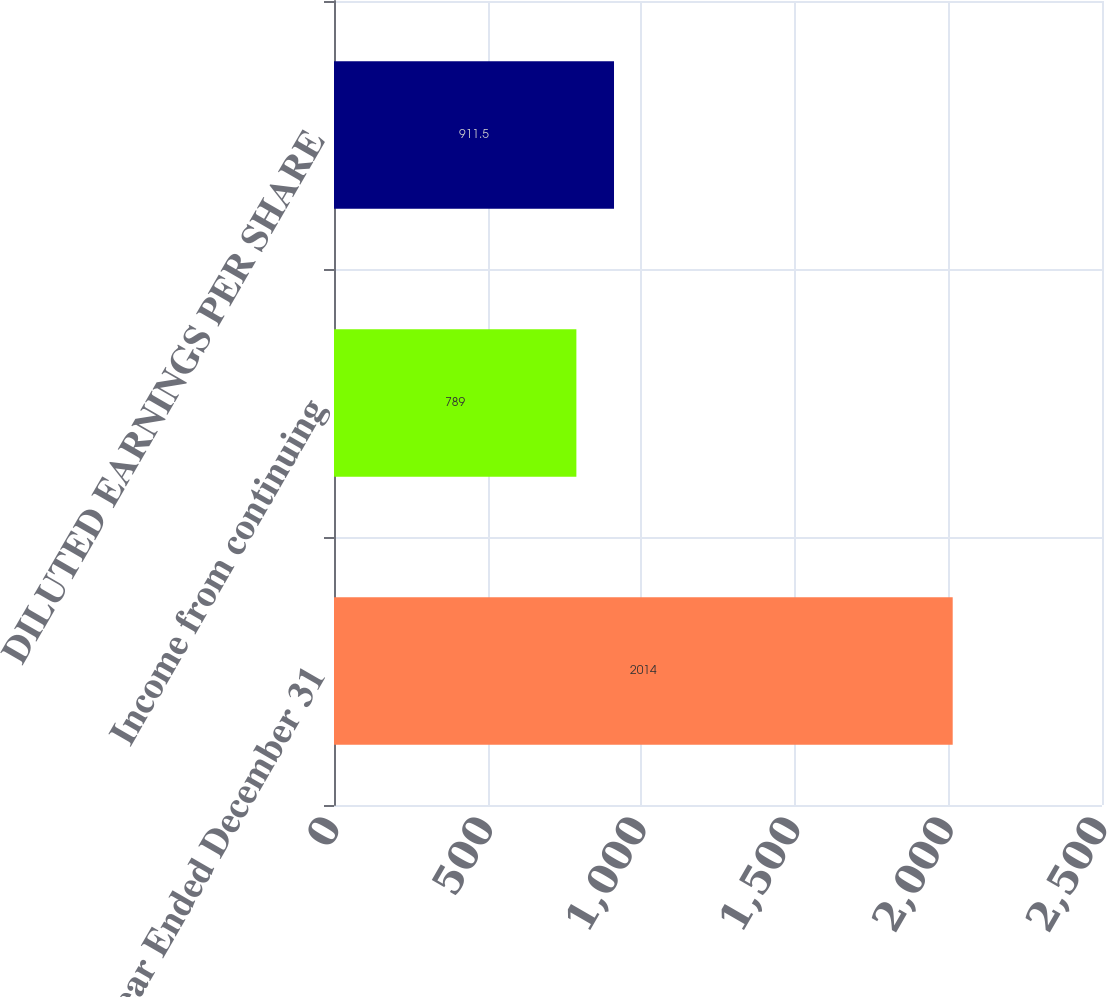<chart> <loc_0><loc_0><loc_500><loc_500><bar_chart><fcel>Year Ended December 31<fcel>Income from continuing<fcel>DILUTED EARNINGS PER SHARE<nl><fcel>2014<fcel>789<fcel>911.5<nl></chart> 